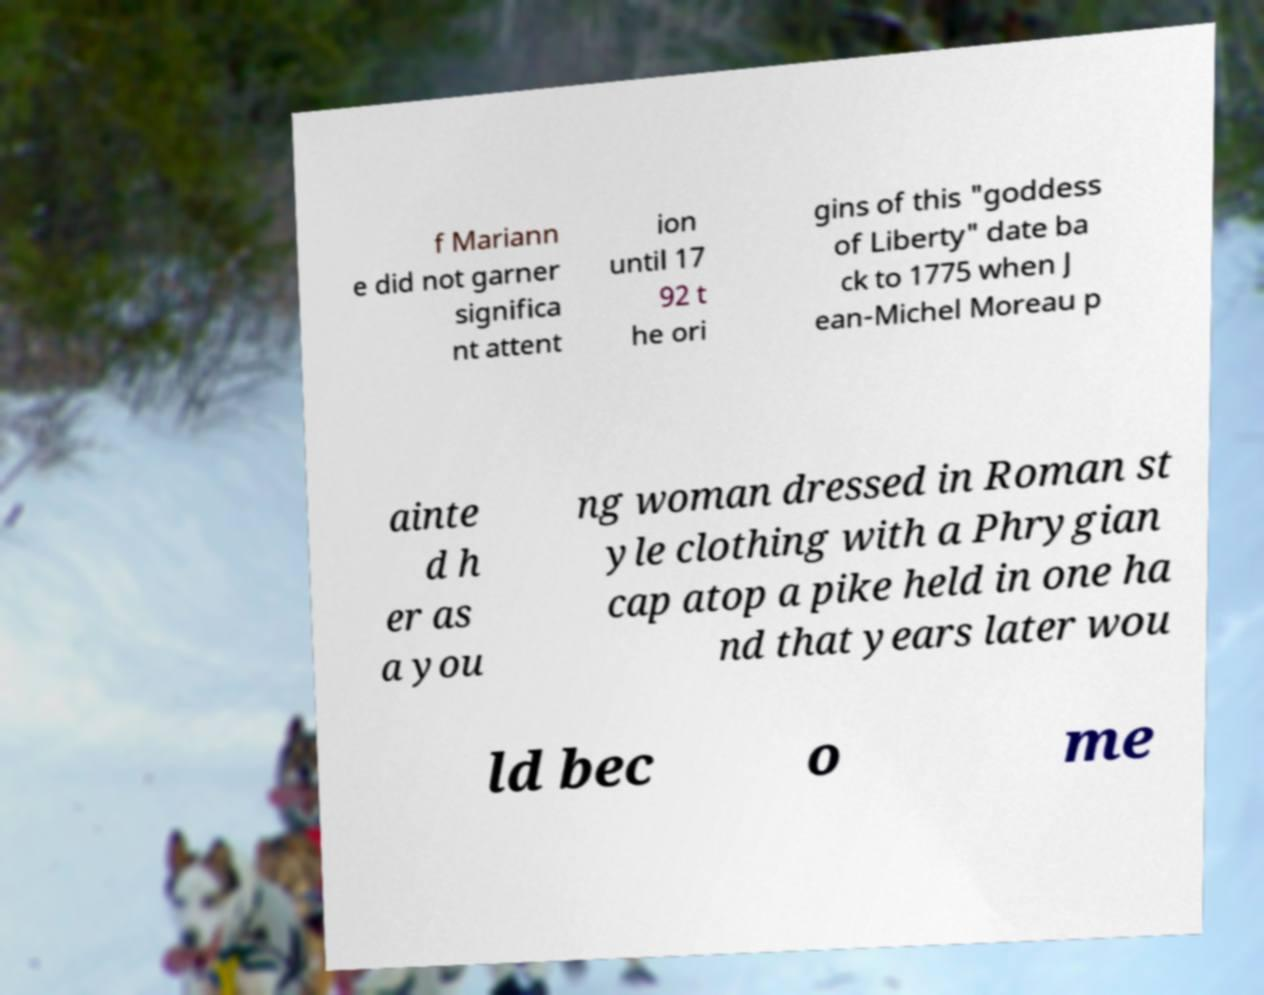I need the written content from this picture converted into text. Can you do that? f Mariann e did not garner significa nt attent ion until 17 92 t he ori gins of this "goddess of Liberty" date ba ck to 1775 when J ean-Michel Moreau p ainte d h er as a you ng woman dressed in Roman st yle clothing with a Phrygian cap atop a pike held in one ha nd that years later wou ld bec o me 